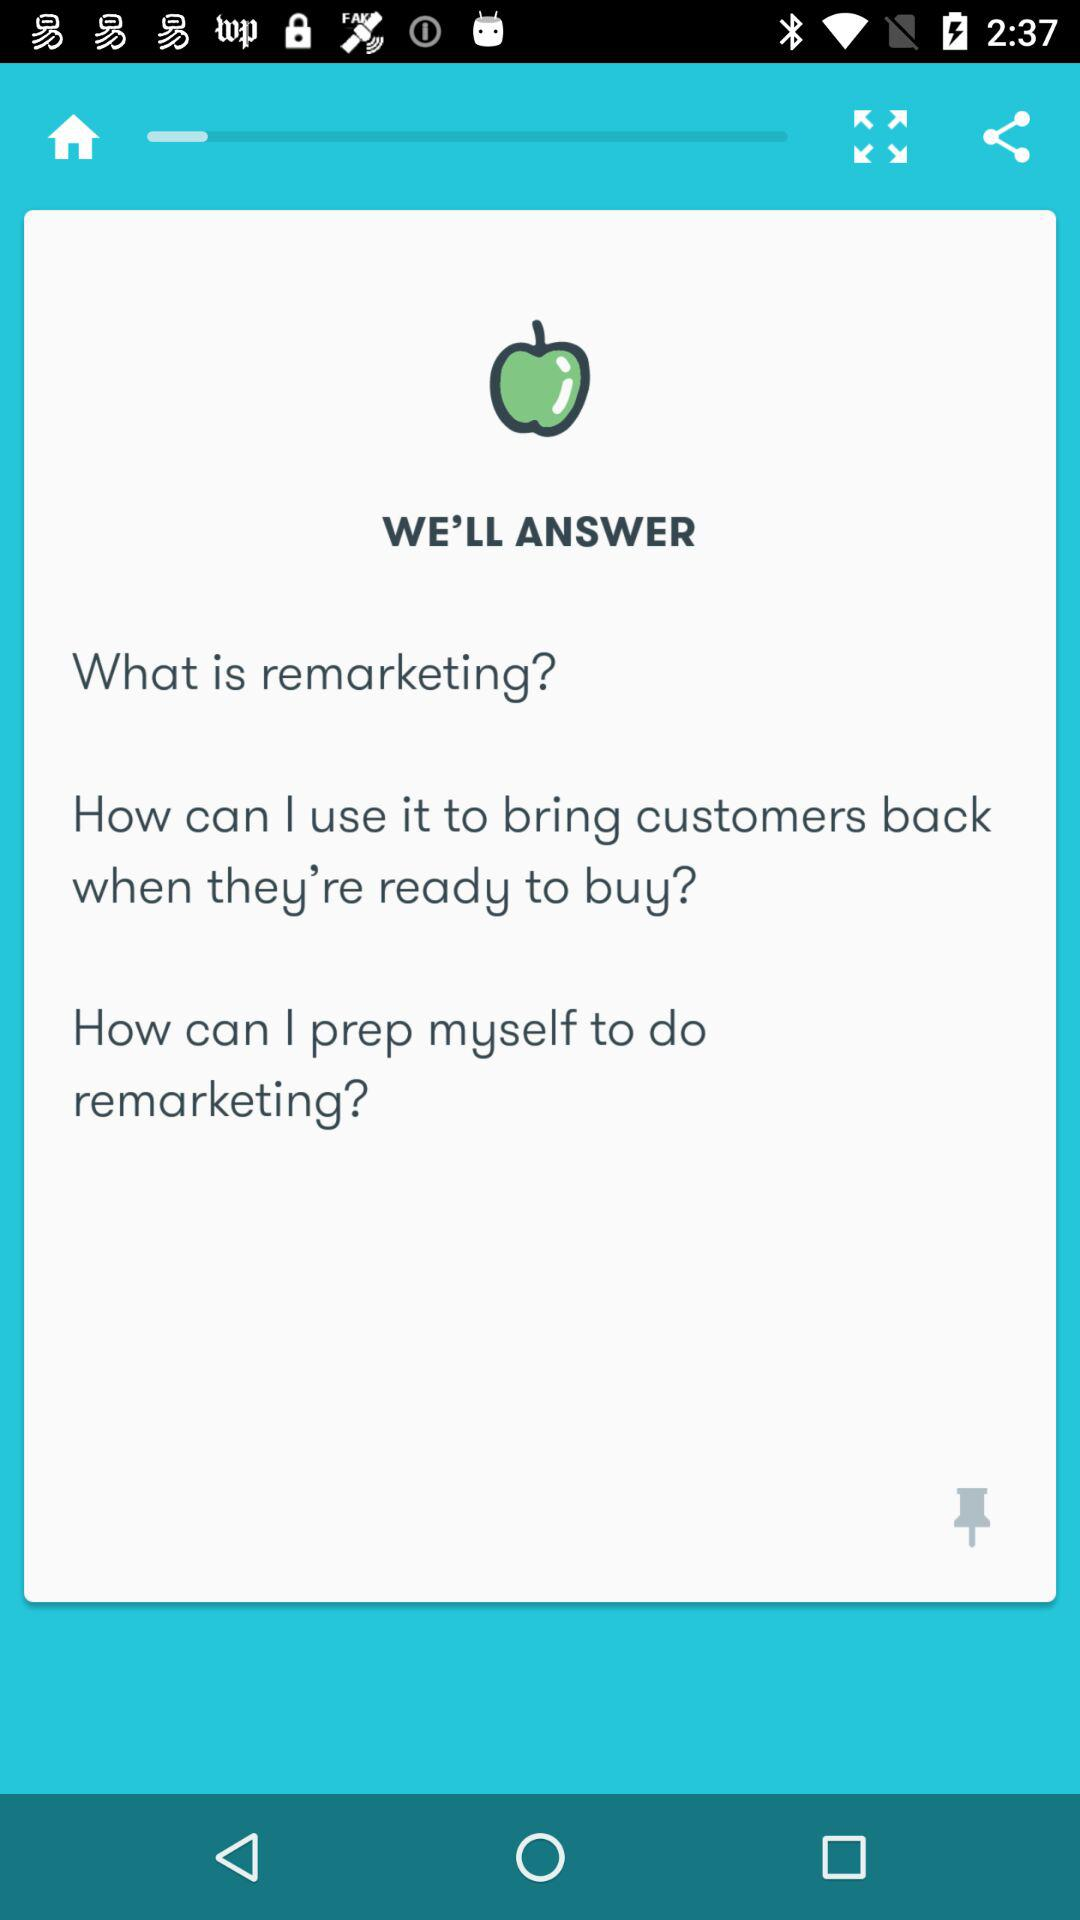How many sections are there in this screen?
Answer the question using a single word or phrase. 3 